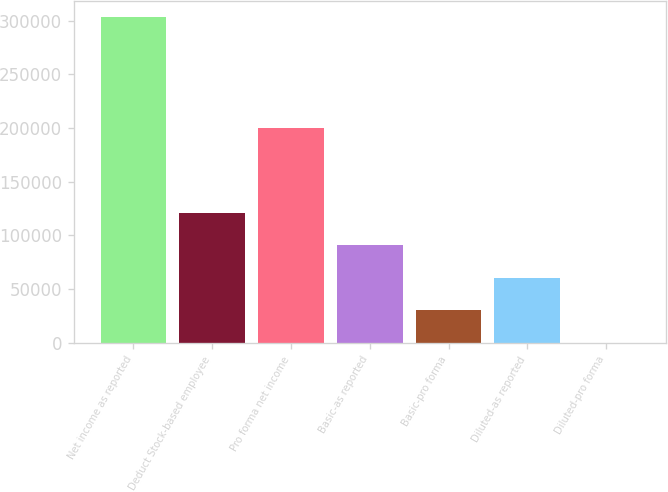Convert chart. <chart><loc_0><loc_0><loc_500><loc_500><bar_chart><fcel>Net income as reported<fcel>Deduct Stock-based employee<fcel>Pro forma net income<fcel>Basic-as reported<fcel>Basic-pro forma<fcel>Diluted-as reported<fcel>Diluted-pro forma<nl><fcel>302989<fcel>121196<fcel>199914<fcel>90897.1<fcel>30299.4<fcel>60598.2<fcel>0.56<nl></chart> 